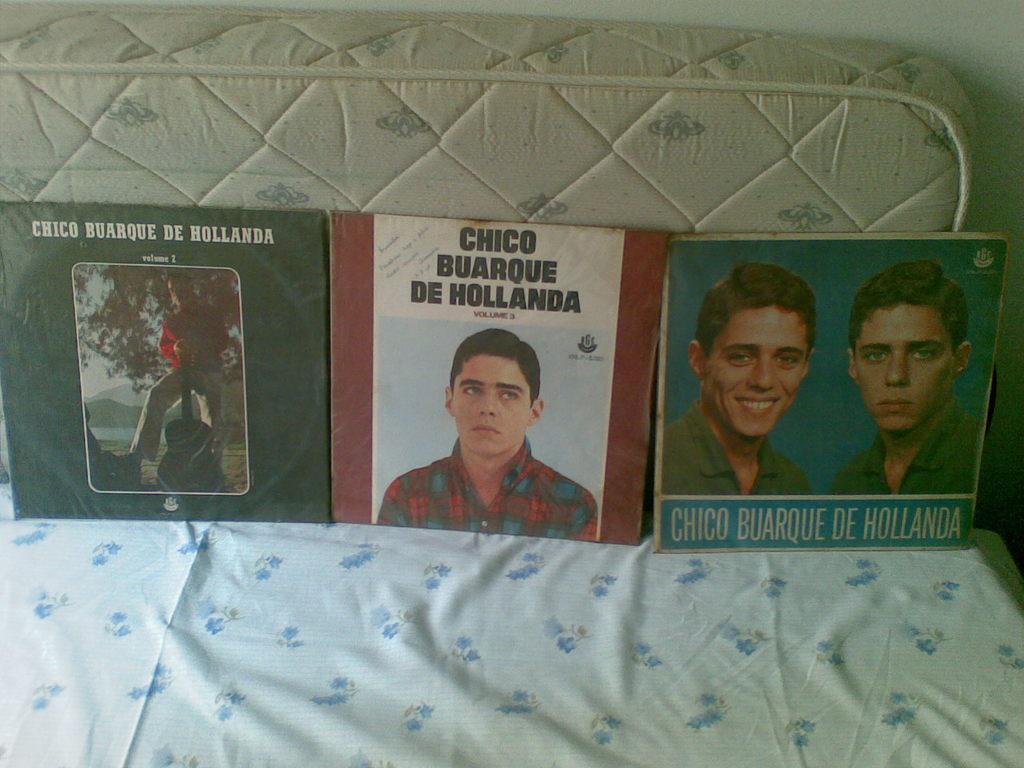Describe this image in one or two sentences. In this image we can see books placed on the cloth. In the background we can see a mattress and a wall. 